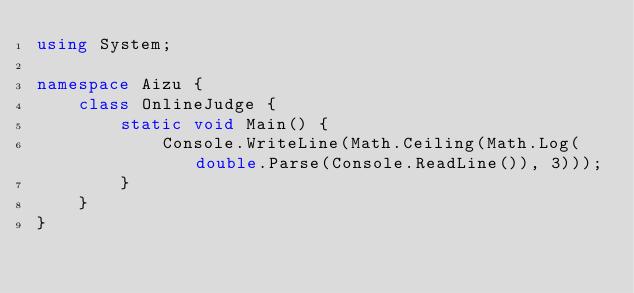<code> <loc_0><loc_0><loc_500><loc_500><_C#_>using System;

namespace Aizu {
    class OnlineJudge {
        static void Main() {
            Console.WriteLine(Math.Ceiling(Math.Log(double.Parse(Console.ReadLine()), 3)));
        }
    }
}</code> 